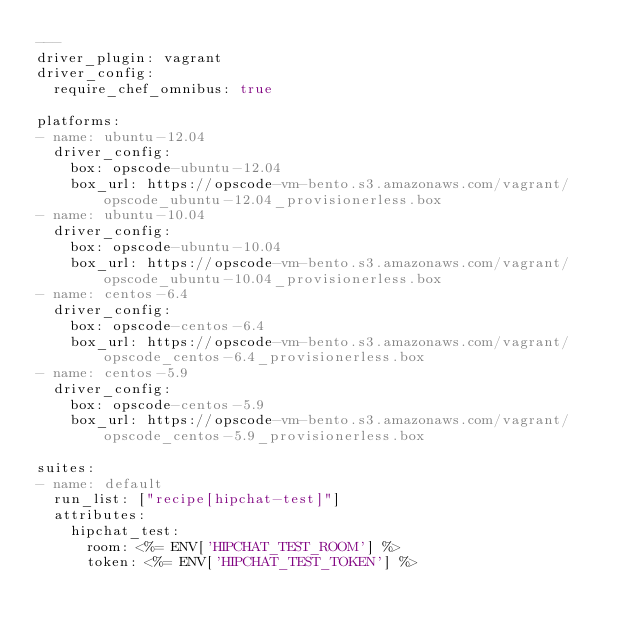<code> <loc_0><loc_0><loc_500><loc_500><_YAML_>---
driver_plugin: vagrant
driver_config:
  require_chef_omnibus: true

platforms:
- name: ubuntu-12.04
  driver_config:
    box: opscode-ubuntu-12.04
    box_url: https://opscode-vm-bento.s3.amazonaws.com/vagrant/opscode_ubuntu-12.04_provisionerless.box
- name: ubuntu-10.04
  driver_config:
    box: opscode-ubuntu-10.04
    box_url: https://opscode-vm-bento.s3.amazonaws.com/vagrant/opscode_ubuntu-10.04_provisionerless.box
- name: centos-6.4
  driver_config:
    box: opscode-centos-6.4
    box_url: https://opscode-vm-bento.s3.amazonaws.com/vagrant/opscode_centos-6.4_provisionerless.box
- name: centos-5.9
  driver_config:
    box: opscode-centos-5.9
    box_url: https://opscode-vm-bento.s3.amazonaws.com/vagrant/opscode_centos-5.9_provisionerless.box

suites:
- name: default
  run_list: ["recipe[hipchat-test]"]
  attributes:
    hipchat_test:
      room: <%= ENV['HIPCHAT_TEST_ROOM'] %>
      token: <%= ENV['HIPCHAT_TEST_TOKEN'] %>
</code> 